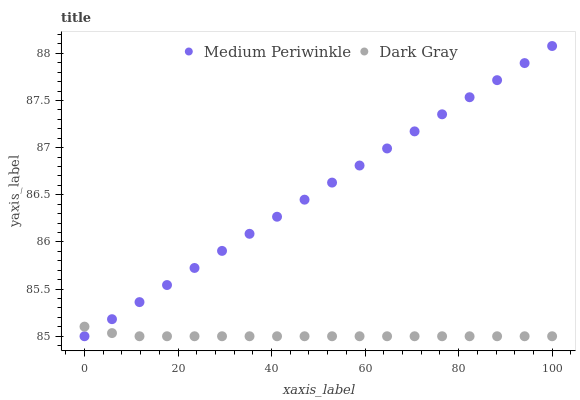Does Dark Gray have the minimum area under the curve?
Answer yes or no. Yes. Does Medium Periwinkle have the maximum area under the curve?
Answer yes or no. Yes. Does Medium Periwinkle have the minimum area under the curve?
Answer yes or no. No. Is Medium Periwinkle the smoothest?
Answer yes or no. Yes. Is Dark Gray the roughest?
Answer yes or no. Yes. Is Medium Periwinkle the roughest?
Answer yes or no. No. Does Dark Gray have the lowest value?
Answer yes or no. Yes. Does Medium Periwinkle have the highest value?
Answer yes or no. Yes. Does Medium Periwinkle intersect Dark Gray?
Answer yes or no. Yes. Is Medium Periwinkle less than Dark Gray?
Answer yes or no. No. Is Medium Periwinkle greater than Dark Gray?
Answer yes or no. No. 